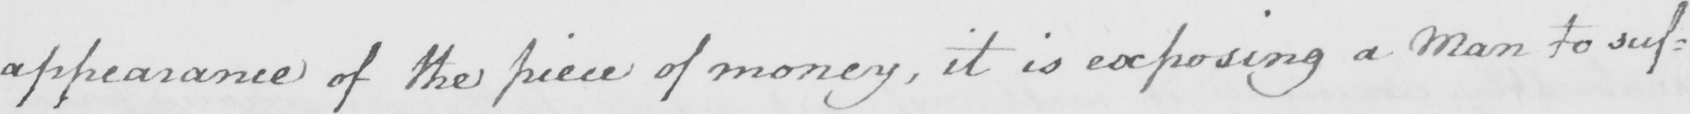What is written in this line of handwriting? appearance of the piece of money , it is exposing a Man to suf= 